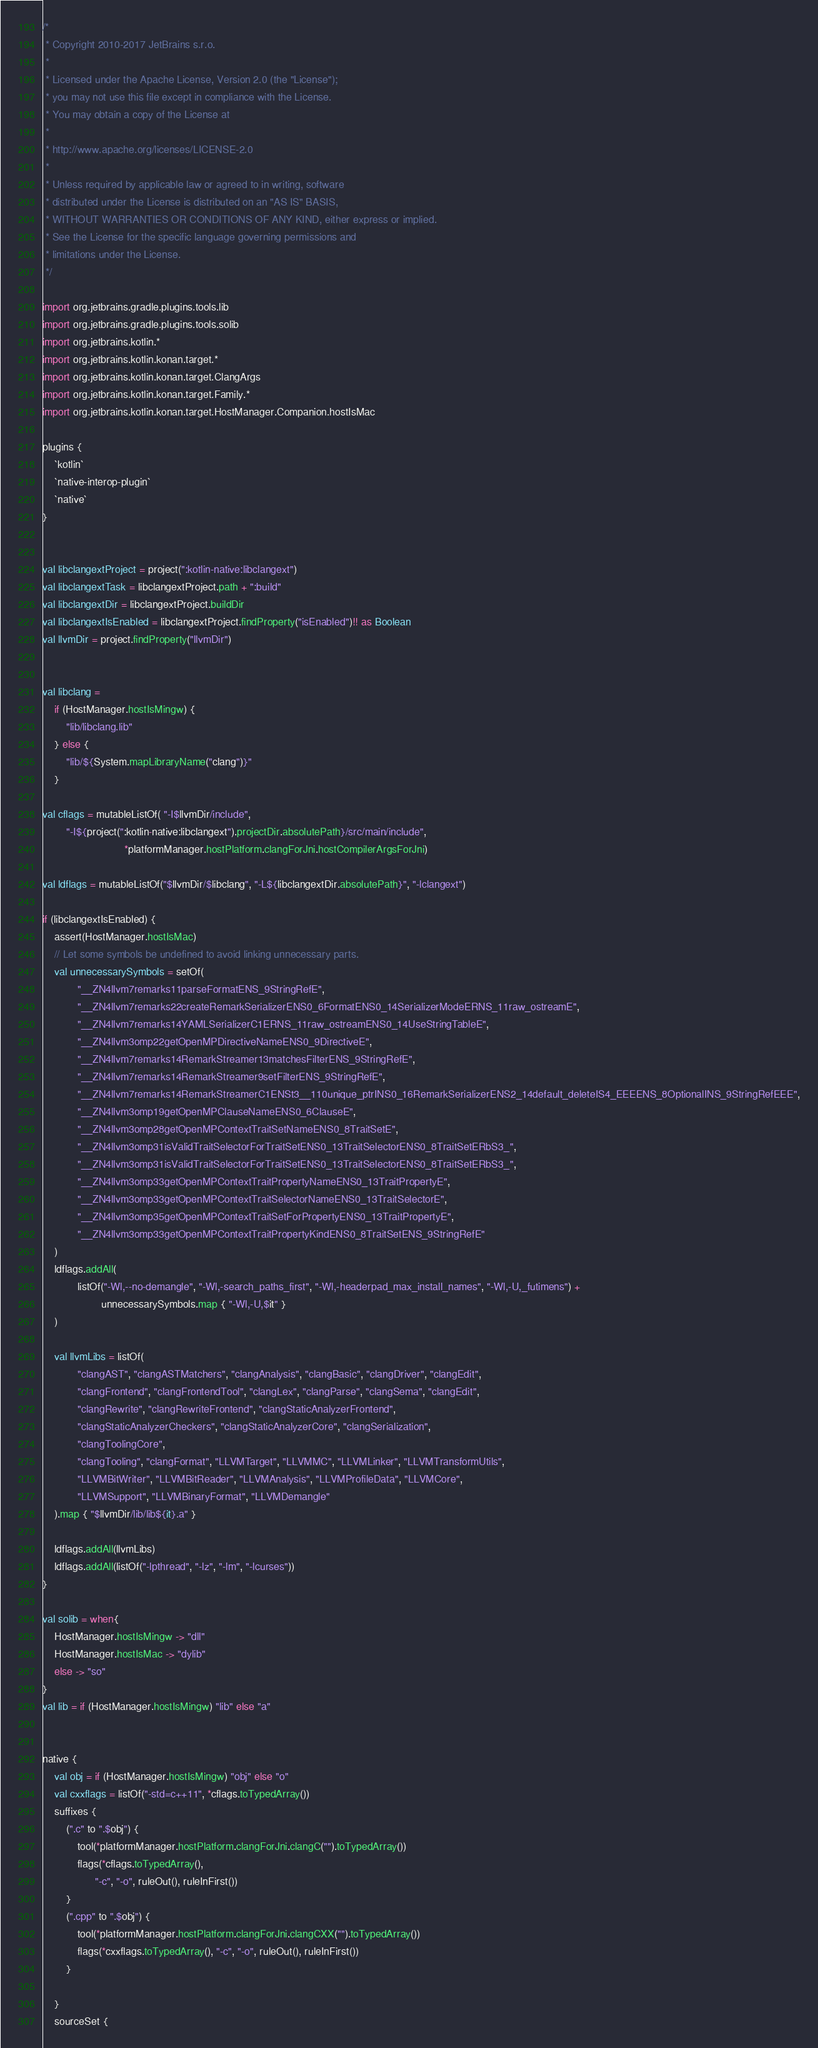Convert code to text. <code><loc_0><loc_0><loc_500><loc_500><_Kotlin_>/*
 * Copyright 2010-2017 JetBrains s.r.o.
 *
 * Licensed under the Apache License, Version 2.0 (the "License");
 * you may not use this file except in compliance with the License.
 * You may obtain a copy of the License at
 *
 * http://www.apache.org/licenses/LICENSE-2.0
 *
 * Unless required by applicable law or agreed to in writing, software
 * distributed under the License is distributed on an "AS IS" BASIS,
 * WITHOUT WARRANTIES OR CONDITIONS OF ANY KIND, either express or implied.
 * See the License for the specific language governing permissions and
 * limitations under the License.
 */

import org.jetbrains.gradle.plugins.tools.lib
import org.jetbrains.gradle.plugins.tools.solib
import org.jetbrains.kotlin.*
import org.jetbrains.kotlin.konan.target.*
import org.jetbrains.kotlin.konan.target.ClangArgs
import org.jetbrains.kotlin.konan.target.Family.*
import org.jetbrains.kotlin.konan.target.HostManager.Companion.hostIsMac

plugins {
    `kotlin`
    `native-interop-plugin`
    `native`
}


val libclangextProject = project(":kotlin-native:libclangext")
val libclangextTask = libclangextProject.path + ":build"
val libclangextDir = libclangextProject.buildDir
val libclangextIsEnabled = libclangextProject.findProperty("isEnabled")!! as Boolean
val llvmDir = project.findProperty("llvmDir")


val libclang =
    if (HostManager.hostIsMingw) {
        "lib/libclang.lib"
    } else {
        "lib/${System.mapLibraryName("clang")}"
    }

val cflags = mutableListOf( "-I$llvmDir/include",
        "-I${project(":kotlin-native:libclangext").projectDir.absolutePath}/src/main/include",
                            *platformManager.hostPlatform.clangForJni.hostCompilerArgsForJni)

val ldflags = mutableListOf("$llvmDir/$libclang", "-L${libclangextDir.absolutePath}", "-lclangext")

if (libclangextIsEnabled) {
    assert(HostManager.hostIsMac)
    // Let some symbols be undefined to avoid linking unnecessary parts.
    val unnecessarySymbols = setOf(
            "__ZN4llvm7remarks11parseFormatENS_9StringRefE",
            "__ZN4llvm7remarks22createRemarkSerializerENS0_6FormatENS0_14SerializerModeERNS_11raw_ostreamE",
            "__ZN4llvm7remarks14YAMLSerializerC1ERNS_11raw_ostreamENS0_14UseStringTableE",
            "__ZN4llvm3omp22getOpenMPDirectiveNameENS0_9DirectiveE",
            "__ZN4llvm7remarks14RemarkStreamer13matchesFilterENS_9StringRefE",
            "__ZN4llvm7remarks14RemarkStreamer9setFilterENS_9StringRefE",
            "__ZN4llvm7remarks14RemarkStreamerC1ENSt3__110unique_ptrINS0_16RemarkSerializerENS2_14default_deleteIS4_EEEENS_8OptionalINS_9StringRefEEE",
            "__ZN4llvm3omp19getOpenMPClauseNameENS0_6ClauseE",
            "__ZN4llvm3omp28getOpenMPContextTraitSetNameENS0_8TraitSetE",
            "__ZN4llvm3omp31isValidTraitSelectorForTraitSetENS0_13TraitSelectorENS0_8TraitSetERbS3_",
            "__ZN4llvm3omp31isValidTraitSelectorForTraitSetENS0_13TraitSelectorENS0_8TraitSetERbS3_",
            "__ZN4llvm3omp33getOpenMPContextTraitPropertyNameENS0_13TraitPropertyE",
            "__ZN4llvm3omp33getOpenMPContextTraitSelectorNameENS0_13TraitSelectorE",
            "__ZN4llvm3omp35getOpenMPContextTraitSetForPropertyENS0_13TraitPropertyE",
            "__ZN4llvm3omp33getOpenMPContextTraitPropertyKindENS0_8TraitSetENS_9StringRefE"
    )
    ldflags.addAll(
            listOf("-Wl,--no-demangle", "-Wl,-search_paths_first", "-Wl,-headerpad_max_install_names", "-Wl,-U,_futimens") +
                    unnecessarySymbols.map { "-Wl,-U,$it" }
    )

    val llvmLibs = listOf(
            "clangAST", "clangASTMatchers", "clangAnalysis", "clangBasic", "clangDriver", "clangEdit",
            "clangFrontend", "clangFrontendTool", "clangLex", "clangParse", "clangSema", "clangEdit",
            "clangRewrite", "clangRewriteFrontend", "clangStaticAnalyzerFrontend",
            "clangStaticAnalyzerCheckers", "clangStaticAnalyzerCore", "clangSerialization",
            "clangToolingCore",
            "clangTooling", "clangFormat", "LLVMTarget", "LLVMMC", "LLVMLinker", "LLVMTransformUtils",
            "LLVMBitWriter", "LLVMBitReader", "LLVMAnalysis", "LLVMProfileData", "LLVMCore",
            "LLVMSupport", "LLVMBinaryFormat", "LLVMDemangle"
    ).map { "$llvmDir/lib/lib${it}.a" }

    ldflags.addAll(llvmLibs)
    ldflags.addAll(listOf("-lpthread", "-lz", "-lm", "-lcurses"))
}

val solib = when{
    HostManager.hostIsMingw -> "dll"
    HostManager.hostIsMac -> "dylib"
    else -> "so"
}
val lib = if (HostManager.hostIsMingw) "lib" else "a"


native {
    val obj = if (HostManager.hostIsMingw) "obj" else "o"
    val cxxflags = listOf("-std=c++11", *cflags.toTypedArray())
    suffixes {
        (".c" to ".$obj") {
            tool(*platformManager.hostPlatform.clangForJni.clangC("").toTypedArray())
            flags(*cflags.toTypedArray(),
                  "-c", "-o", ruleOut(), ruleInFirst())
        }
        (".cpp" to ".$obj") {
            tool(*platformManager.hostPlatform.clangForJni.clangCXX("").toTypedArray())
            flags(*cxxflags.toTypedArray(), "-c", "-o", ruleOut(), ruleInFirst())
        }

    }
    sourceSet {</code> 